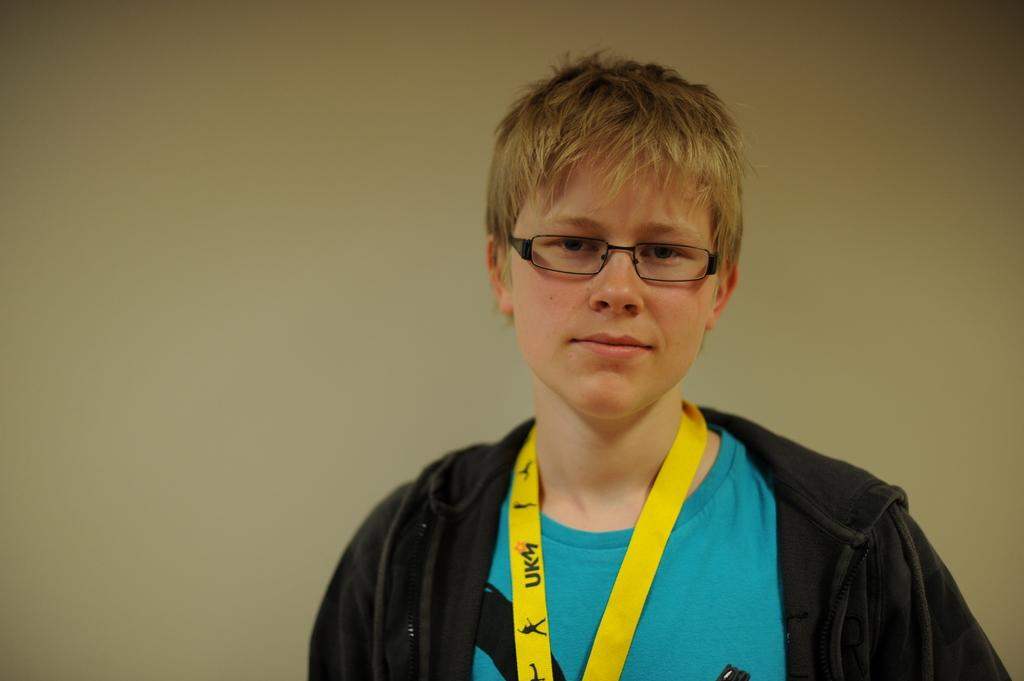Who is the main subject in the image? There is a person in the center of the image. What accessory is the person wearing? The person is wearing glasses. What can be seen in the background of the image? There is a wall in the background of the image. What type of school does the person in the image attend? There is no information about a school or any educational institution in the image. 